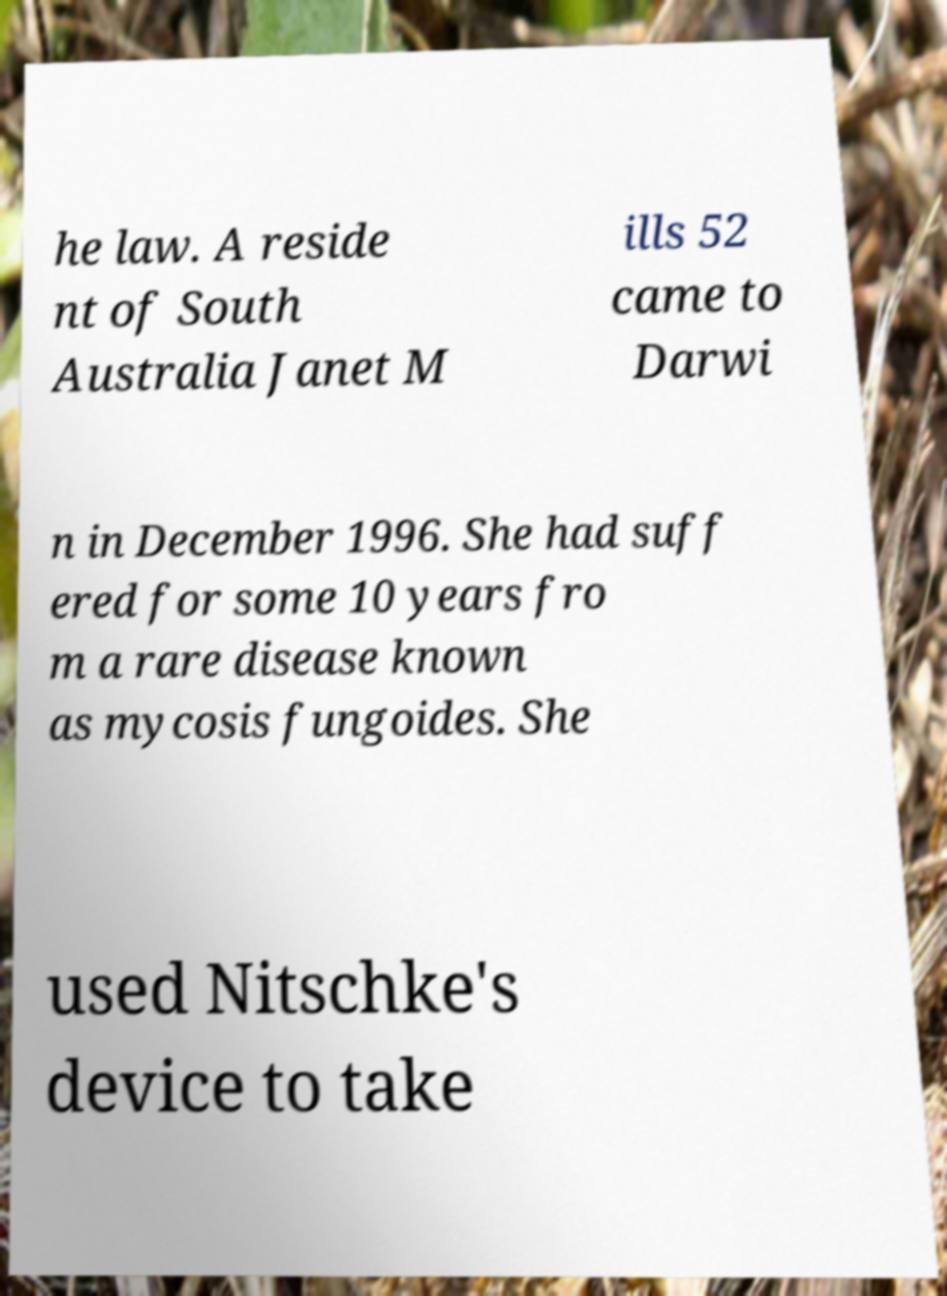Can you read and provide the text displayed in the image?This photo seems to have some interesting text. Can you extract and type it out for me? he law. A reside nt of South Australia Janet M ills 52 came to Darwi n in December 1996. She had suff ered for some 10 years fro m a rare disease known as mycosis fungoides. She used Nitschke's device to take 